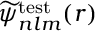<formula> <loc_0><loc_0><loc_500><loc_500>\widetilde { \psi } _ { n l m } ^ { t e s t } ( r )</formula> 